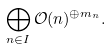<formula> <loc_0><loc_0><loc_500><loc_500>\bigoplus _ { n \in I } \mathcal { O } ( n ) ^ { \oplus m _ { n } } .</formula> 